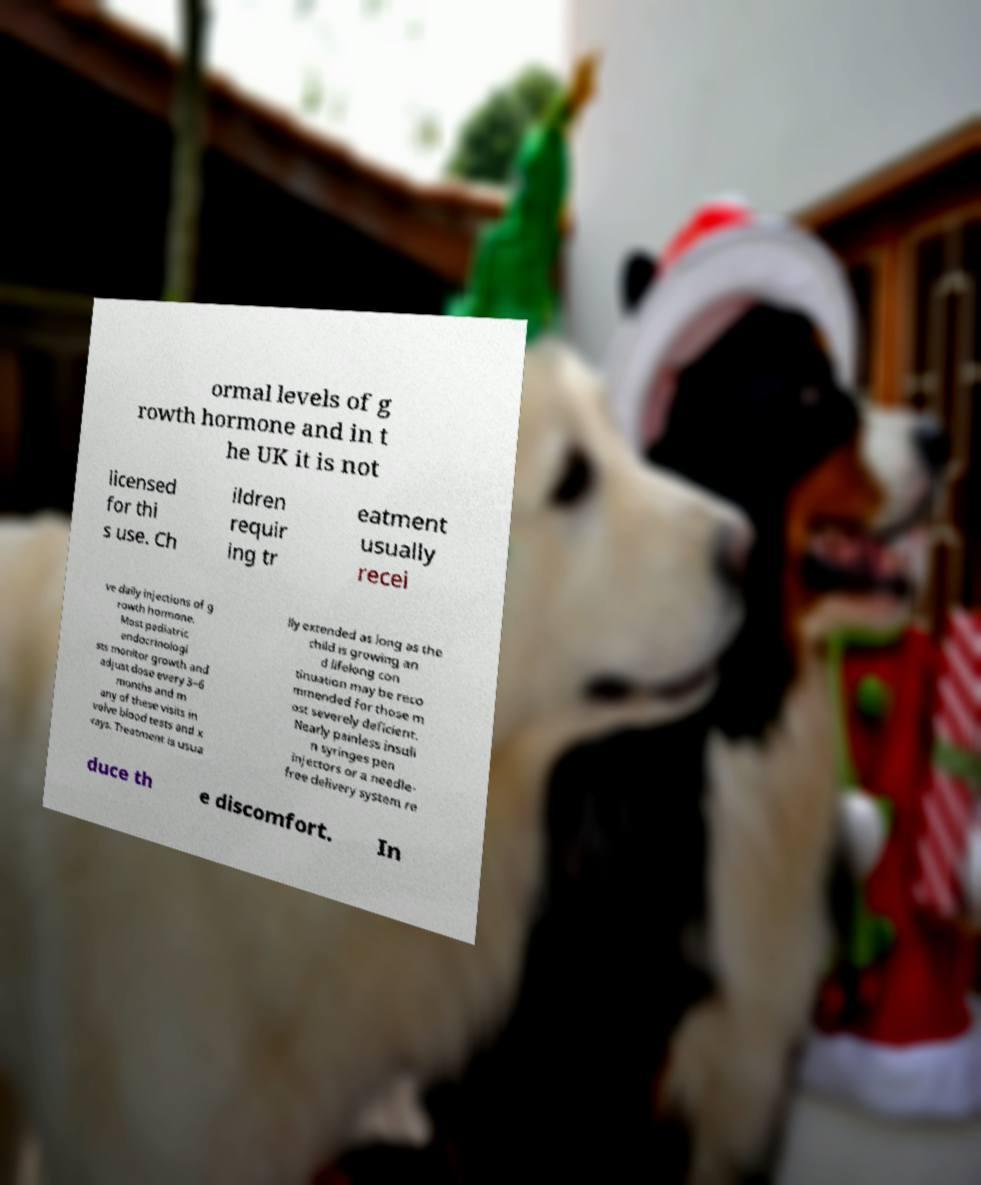Could you assist in decoding the text presented in this image and type it out clearly? ormal levels of g rowth hormone and in t he UK it is not licensed for thi s use. Ch ildren requir ing tr eatment usually recei ve daily injections of g rowth hormone. Most pediatric endocrinologi sts monitor growth and adjust dose every 3–6 months and m any of these visits in volve blood tests and x -rays. Treatment is usua lly extended as long as the child is growing an d lifelong con tinuation may be reco mmended for those m ost severely deficient. Nearly painless insuli n syringes pen injectors or a needle- free delivery system re duce th e discomfort. In 